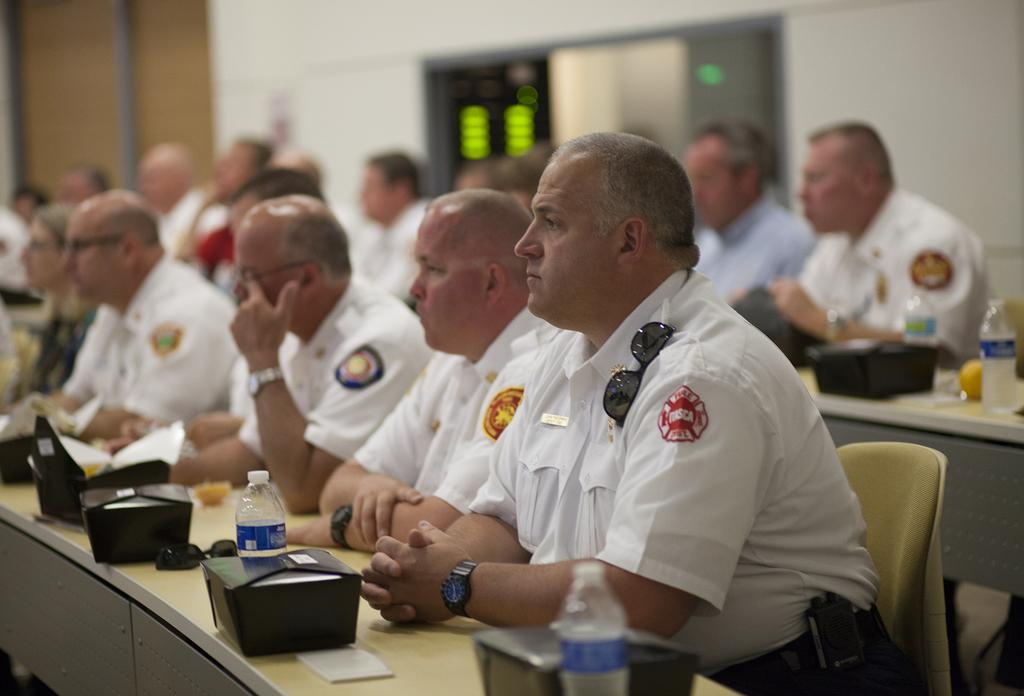What are the people in the image doing? The people in the image are seated. What items can be seen on the tables in the image? There are water bottles, papers, and boxes on the tables. Can you describe the background of the image? There appears to be a door in the background of the image. How many potatoes are on the tables in the image? There are no potatoes present in the image. Can you describe the snails crawling on the door in the background of the image? There are no snails visible in the image; the background only shows a door. 